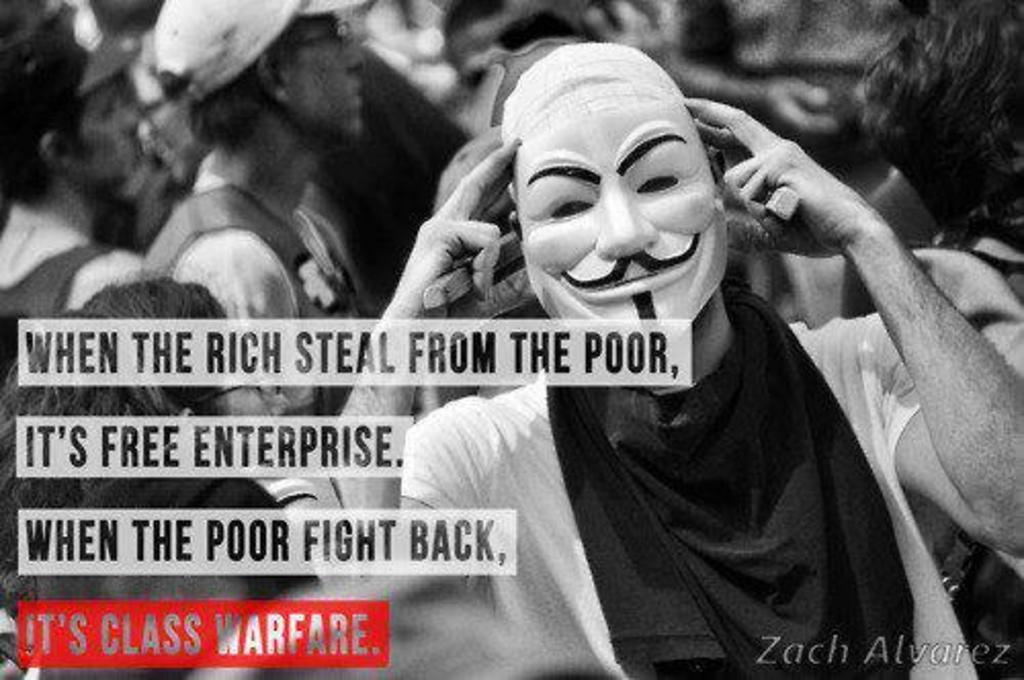How would you summarize this image in a sentence or two? This is a black and white image, in this image there are people standing and there is some text. 